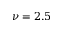Convert formula to latex. <formula><loc_0><loc_0><loc_500><loc_500>\nu = 2 . 5</formula> 